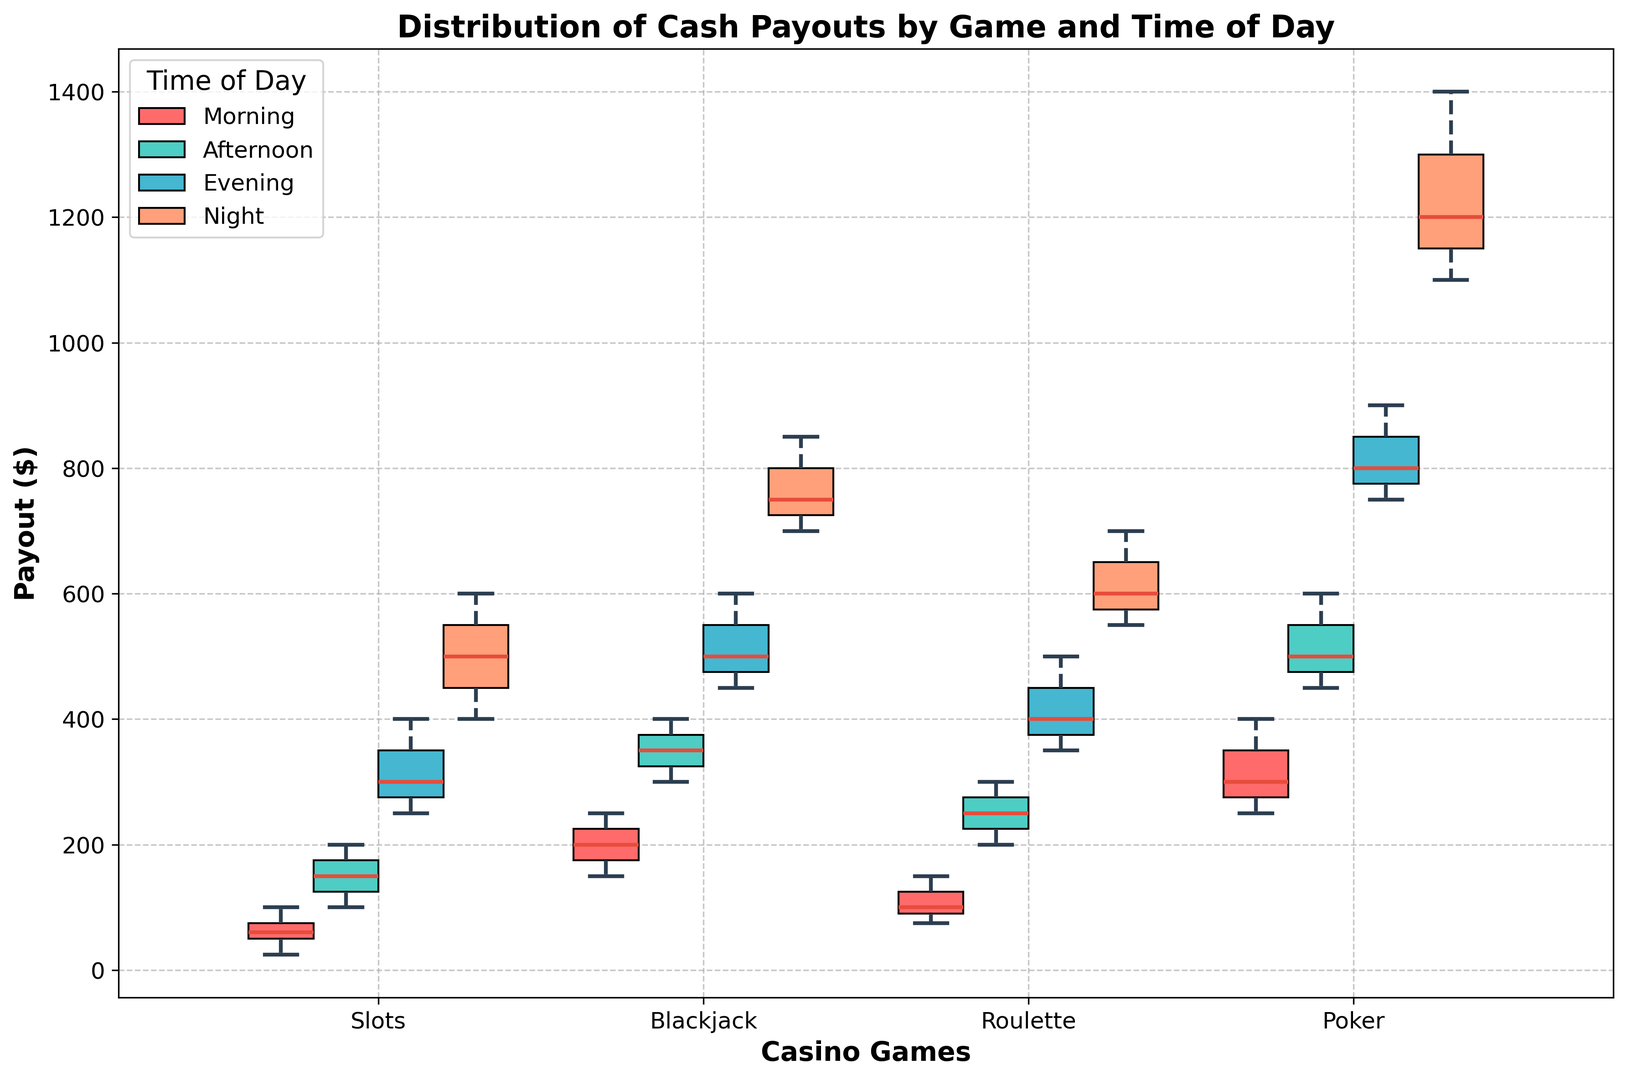Which casino game has the highest median payout in the evening? Observe the medians of the box plots for each casino game during the evening. The medians are usually represented by the horizontal line inside each box plot. Identify the game with the highest median.
Answer: Poker Which time of day shows the widest range of payouts for the game of Slots? The range is the difference between the highest and lowest values (whiskers) of the box plot. Compare the ranges for Slots across different times of day.
Answer: Night For Blackjack, what is the interquartile range (IQR) in the morning? The IQR is the difference between the third quartile (the top of the box) and the first quartile (the bottom of the box). Identify these points on the Blackjack box plot for the morning and calculate the difference.
Answer: 75 Compare the average payouts of Roulette in the afternoon and evening. Which time has a higher average? The average is influenced by the mean line or the central tendency of the box plot. For Roulette, compare the position of the means in the afternoon and evening.
Answer: Evening Which time of day has the most consistent (least variable) payouts for Poker? Consistency is indicated by a smaller interquartile range and shorter whiskers. Identify the tightest box plot for Poker across different times of day.
Answer: Morning What is the range of payouts for Roulette in the evening? The range is calculated by subtracting the lowest value (bottom whisker) from the highest value (top whisker) of the box plot.
Answer: 150 In which time of day does Slots show the highest maximum payout? The maximum payout is represented by the top whisker of the box plot. Identify the highest top whisker for Slots across all times of day.
Answer: Night How do the evening payouts for Poker compare with those for Slots in terms of variability? Variability is reflected by the width of the box plot and the length of the whiskers. Compare the corresponding box plots for Poker and Slots in the evening.
Answer: Poker has higher variability For each game, identify the time of day with the highest median payout. Look at the line inside each box plot, which represents the median. For each game, identify which time of day has the highest line inside the box.
Answer: Slots: Night, Blackjack: Night, Roulette: Night, Poker: Night Which game shows the least variability in payouts overall? Observe the box plots of all games and determine which has the smallest interquartile range and the shortest whiskers across all times of day.
Answer: Blackjack 